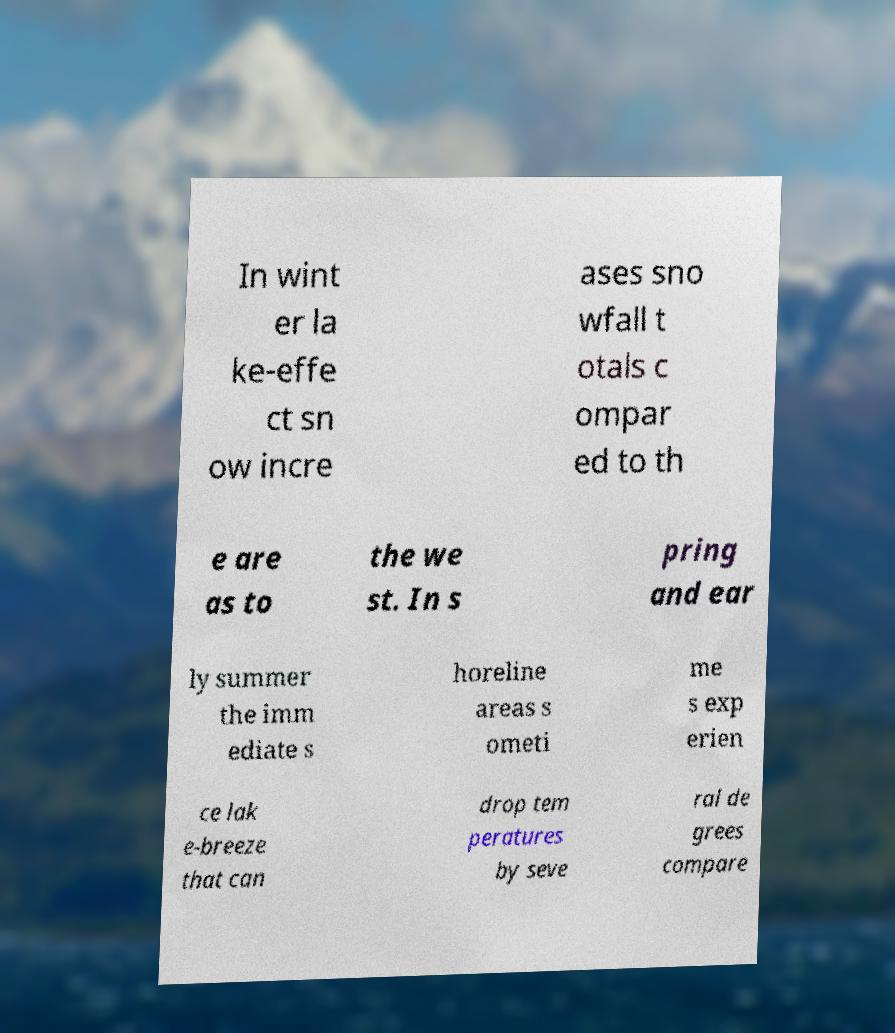Please read and relay the text visible in this image. What does it say? In wint er la ke-effe ct sn ow incre ases sno wfall t otals c ompar ed to th e are as to the we st. In s pring and ear ly summer the imm ediate s horeline areas s ometi me s exp erien ce lak e-breeze that can drop tem peratures by seve ral de grees compare 